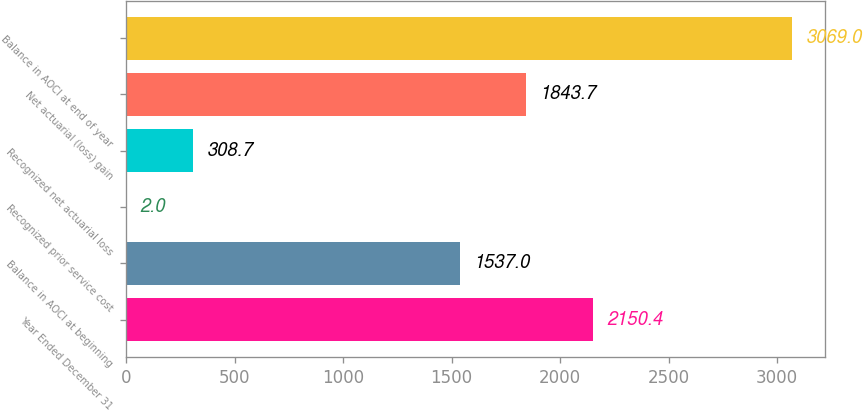Convert chart to OTSL. <chart><loc_0><loc_0><loc_500><loc_500><bar_chart><fcel>Year Ended December 31<fcel>Balance in AOCI at beginning<fcel>Recognized prior service cost<fcel>Recognized net actuarial loss<fcel>Net actuarial (loss) gain<fcel>Balance in AOCI at end of year<nl><fcel>2150.4<fcel>1537<fcel>2<fcel>308.7<fcel>1843.7<fcel>3069<nl></chart> 